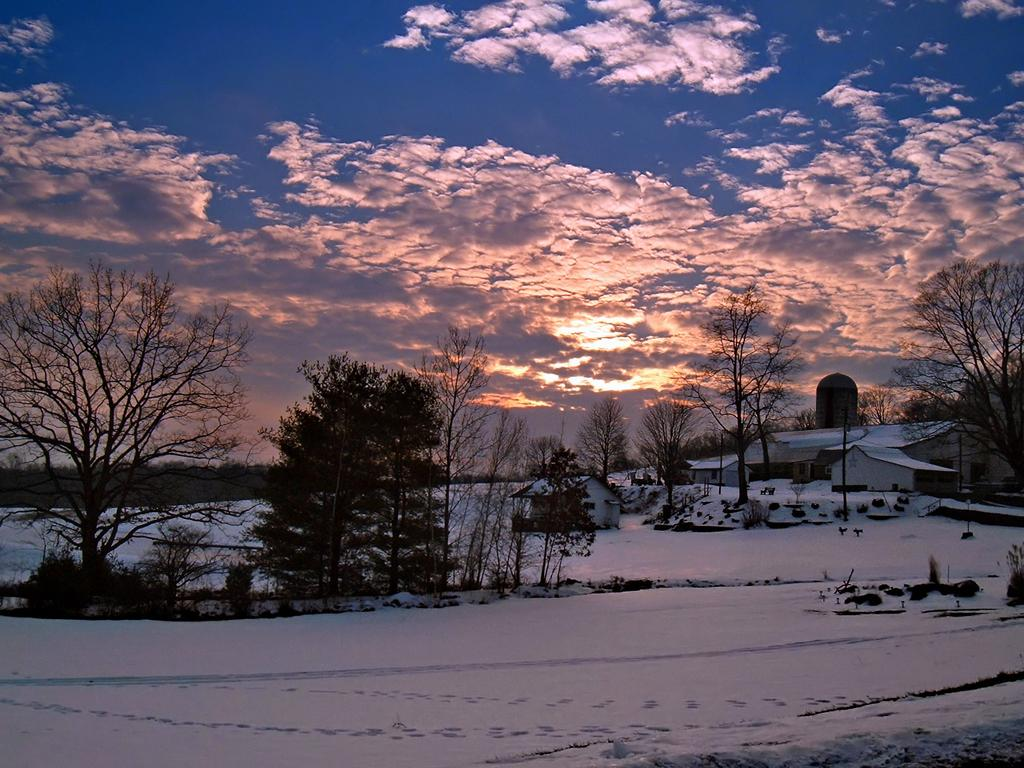What is present at the bottom of the image? There is snow at the bottom of the image. What can be seen in the middle of the image? There are trees, poles, and buildings in the middle of the image. What is visible at the top of the image? There are clouds and the sky visible at the top of the image. What type of noise can be heard coming from the frog in the image? There is no frog present in the image, so it is not possible to determine what noise, if any, might be heard. 